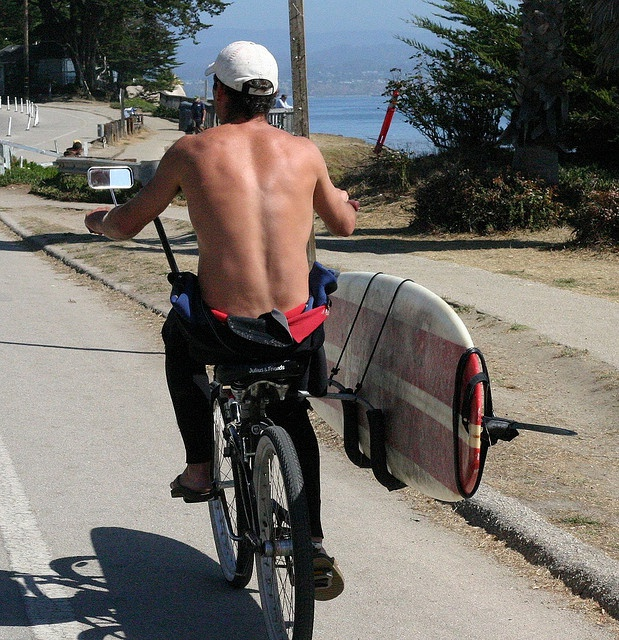Describe the objects in this image and their specific colors. I can see people in black, salmon, maroon, and brown tones, surfboard in black, gray, maroon, and darkgray tones, and bicycle in black, gray, darkgray, and lightgray tones in this image. 